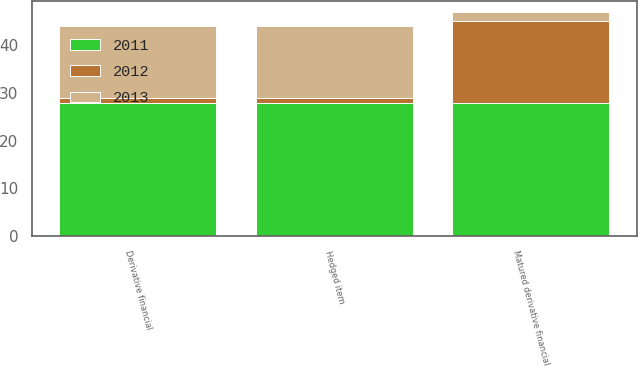Convert chart to OTSL. <chart><loc_0><loc_0><loc_500><loc_500><stacked_bar_chart><ecel><fcel>Derivative financial<fcel>Hedged item<fcel>Matured derivative financial<nl><fcel>2012<fcel>1<fcel>1<fcel>17<nl><fcel>2013<fcel>15<fcel>15<fcel>2<nl><fcel>2011<fcel>28<fcel>28<fcel>28<nl></chart> 